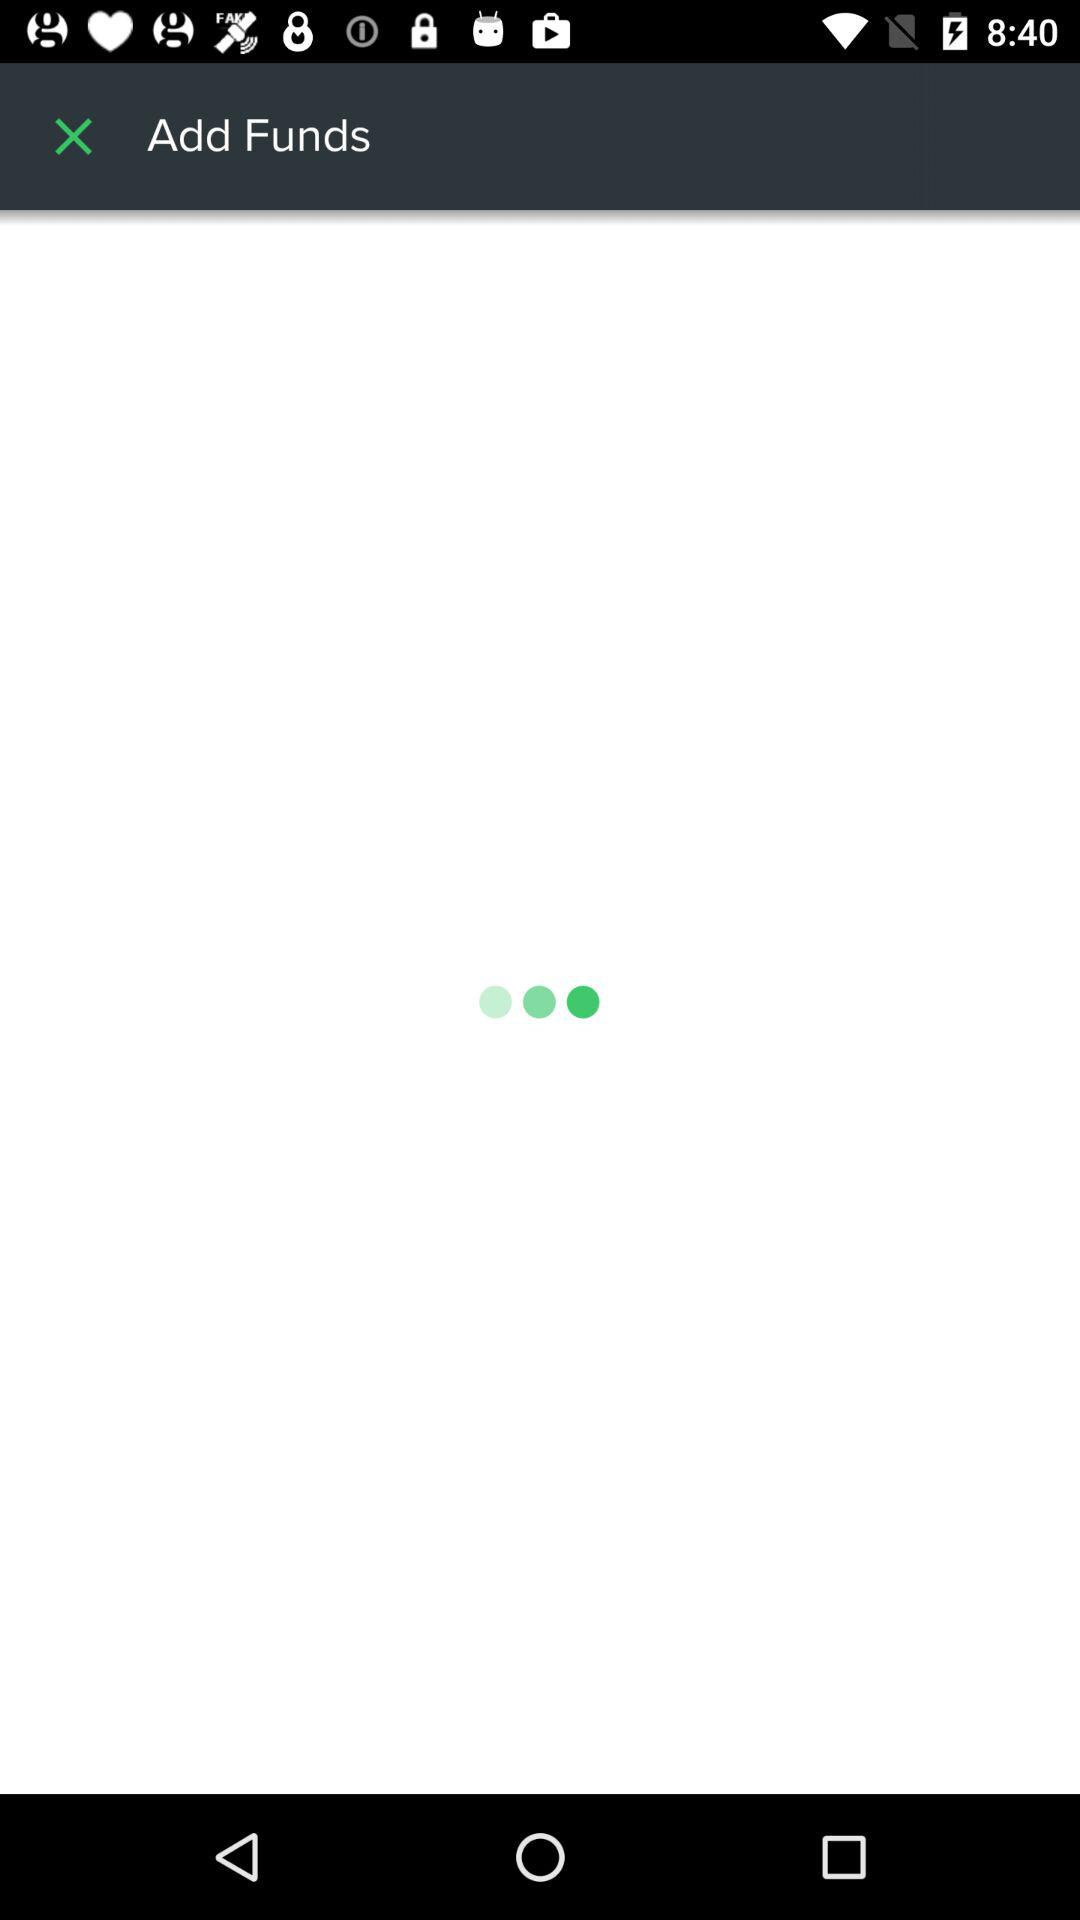How many characters are required for the password?
When the provided information is insufficient, respond with <no answer>. <no answer> 